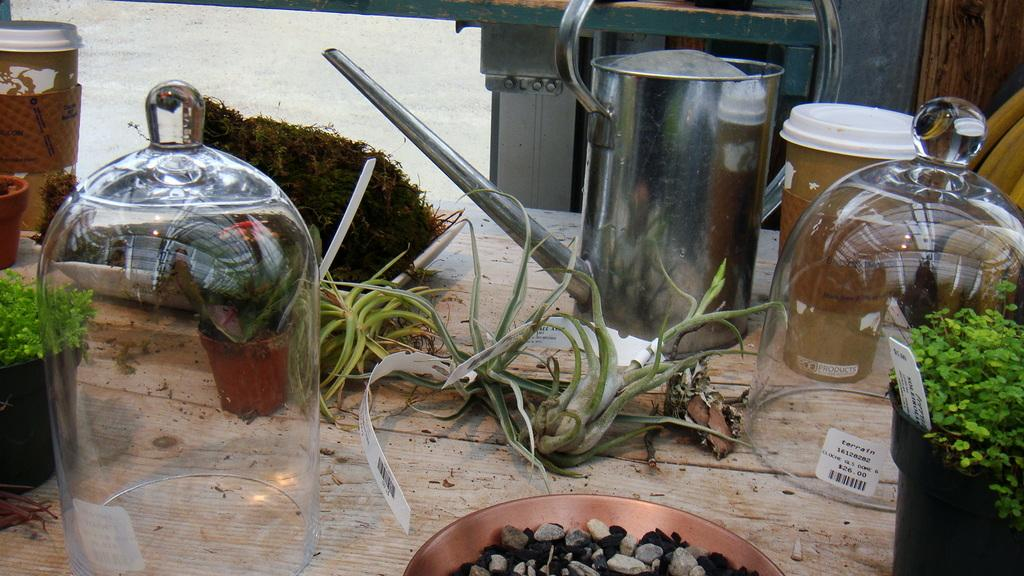What type of table is in the image? There is a wooden table in the image. What can be seen on the wooden table? There are glass containers, a kettle, a planter, a plate with stones, and pots with plants on the table. How many items are visible on the table? There are many other items on the table besides the ones mentioned. What type of band is playing music in the image? There is no band present in the image; it features a wooden table with various items on it. 